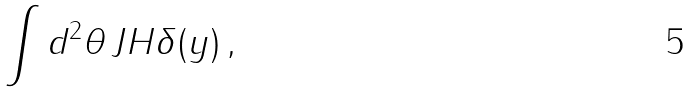<formula> <loc_0><loc_0><loc_500><loc_500>\int d ^ { 2 } \theta \, J H \delta ( y ) \, ,</formula> 